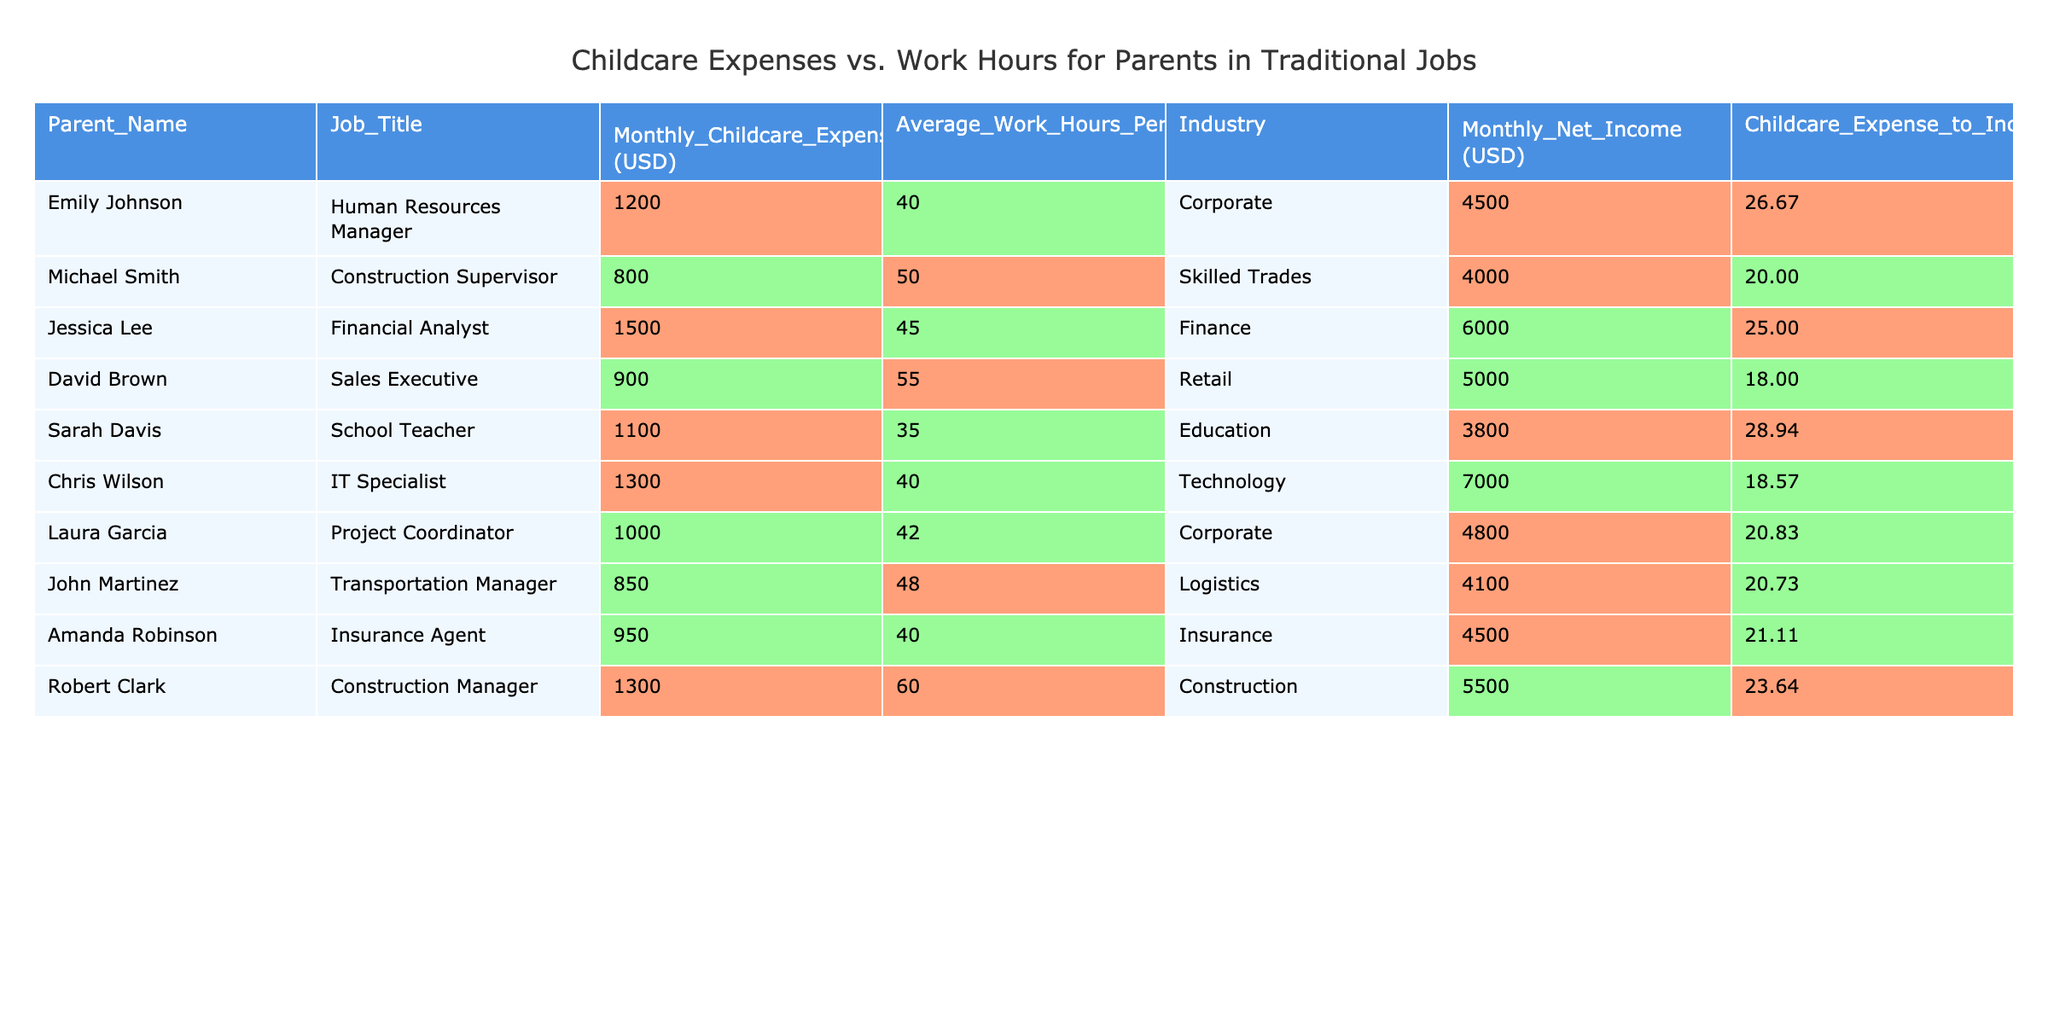What is Emily Johnson's monthly childcare expense? From the table, Emily Johnson's Monthly Childcare Expenses is listed directly as 1200 USD.
Answer: 1200 USD Which parent has the highest childcare expense-to-income ratio? Looking through the Childcare Expense to Income Ratio column, Sarah Davis has the highest ratio at 28.94%.
Answer: Sarah Davis What is the average monthly childcare expense for the parents listed? To find the average, sum up the monthly expenses (1200 + 800 + 1500 + 900 + 1100 + 1300 + 1000 + 850 + 950 + 1300) = 10100, then divide by 10 (the number of parents), giving 1010.
Answer: 1010 USD Is the childcare expense of Chris Wilson greater than the average monthly childcare expense? We found the average monthly childcare expense to be 1010 USD. Chris Wilson's monthly childcare expense is 1300 USD, which is greater than 1010 USD. Thus, the answer is yes.
Answer: Yes What is the total net income for all parents combined? Adding the monthly net incomes together (4500 + 4000 + 6000 + 5000 + 3800 + 7000 + 4800 + 4100 + 4500 + 5500) gives a total of 40800 USD.
Answer: 40800 USD Which parent works the most hours per week, and how many hours do they work? Reviewing the Average Work Hours Per Week, Robert Clark works the most at 60 hours.
Answer: Robert Clark, 60 hours Compare the childcare expenses of Jessica Lee and David Brown. Who pays more? Jessica Lee's childcare expenses are 1500 USD while David Brown's are 900 USD. Since 1500 > 900, Jessica Lee pays more.
Answer: Jessica Lee How many parents have monthly childcare expenses below the average? Since the average monthly childcare expense is 1010 USD, the parents with expenses below this are Michael Smith (800), David Brown (900), and John Martinez (850). That's three parents total.
Answer: 3 parents What is the difference between the lowest and highest monthly net income? The lowest monthly net income is 3800 USD (Sarah Davis) and the highest is 7000 USD (Chris Wilson). The difference calculated is 7000 - 3800 = 3200 USD.
Answer: 3200 USD Are all parents with monthly childcare expenses above 1200 USD also earning more than 4500 USD? Checking the table, the following parents have expenses above 1200 USD: Jessica Lee (1500), Chris Wilson (1300), and Robert Clark (1300). Their monthly net incomes are 6000, 7000, and 5500 USD, respectively, all of which are greater than 4500 USD. Thus, the statement is true.
Answer: Yes If Laura Garcia reduced her childcare expenses by 200 USD, what would her new expense-to-income ratio be? Laura's current expenses are 1000 USD with an income of 4800 USD. After reducing by 200, her expense would be 800 USD. The new ratio is (800 / 4800) * 100 = 16.67%.
Answer: 16.67% 